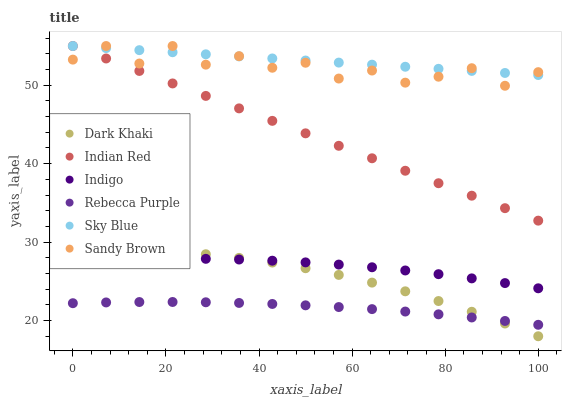Does Rebecca Purple have the minimum area under the curve?
Answer yes or no. Yes. Does Sky Blue have the maximum area under the curve?
Answer yes or no. Yes. Does Dark Khaki have the minimum area under the curve?
Answer yes or no. No. Does Dark Khaki have the maximum area under the curve?
Answer yes or no. No. Is Sky Blue the smoothest?
Answer yes or no. Yes. Is Sandy Brown the roughest?
Answer yes or no. Yes. Is Dark Khaki the smoothest?
Answer yes or no. No. Is Dark Khaki the roughest?
Answer yes or no. No. Does Dark Khaki have the lowest value?
Answer yes or no. Yes. Does Rebecca Purple have the lowest value?
Answer yes or no. No. Does Sandy Brown have the highest value?
Answer yes or no. Yes. Does Dark Khaki have the highest value?
Answer yes or no. No. Is Rebecca Purple less than Indigo?
Answer yes or no. Yes. Is Sandy Brown greater than Indigo?
Answer yes or no. Yes. Does Sandy Brown intersect Sky Blue?
Answer yes or no. Yes. Is Sandy Brown less than Sky Blue?
Answer yes or no. No. Is Sandy Brown greater than Sky Blue?
Answer yes or no. No. Does Rebecca Purple intersect Indigo?
Answer yes or no. No. 